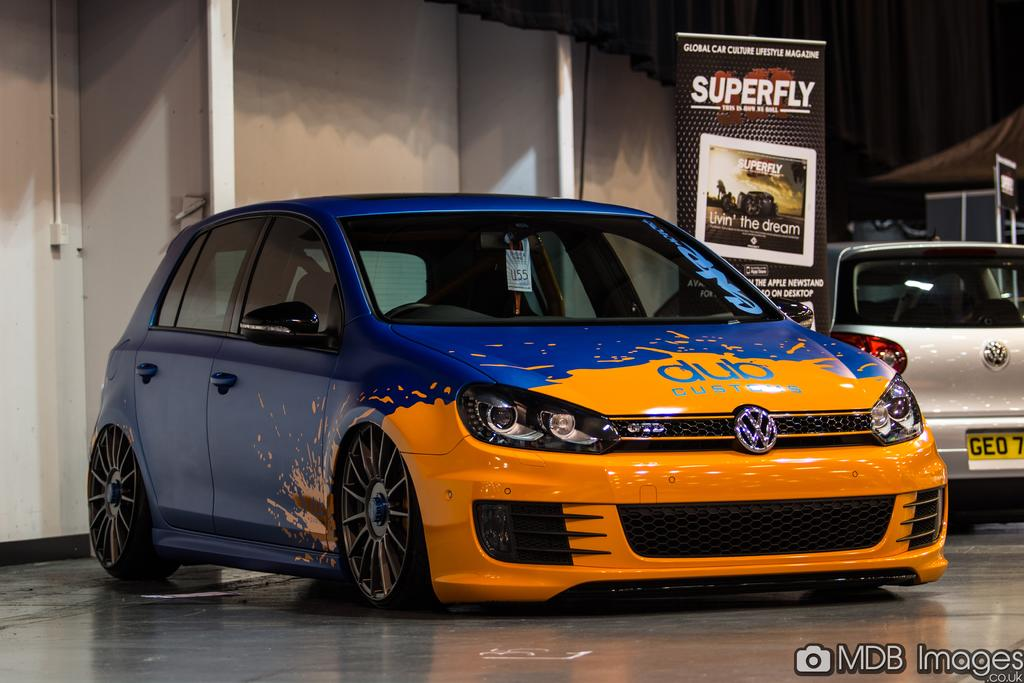What objects are on the floor in the image? There are cars on the floor in the image. What can be seen on the hoarding in the image? The content of the hoarding is not specified in the facts, so we cannot answer this question definitively. What is visible in the background of the image? There is a wall visible in the background of the image. What is present at the bottom of the image? There is a watermark at the bottom of the image. What type of leaf is being used to promote health in the image? There is no leaf or promotion of health present in the image. What type of produce is being advertised on the hoarding in the image? The content of the hoarding is not specified in the facts, so we cannot answer this question definitively. 